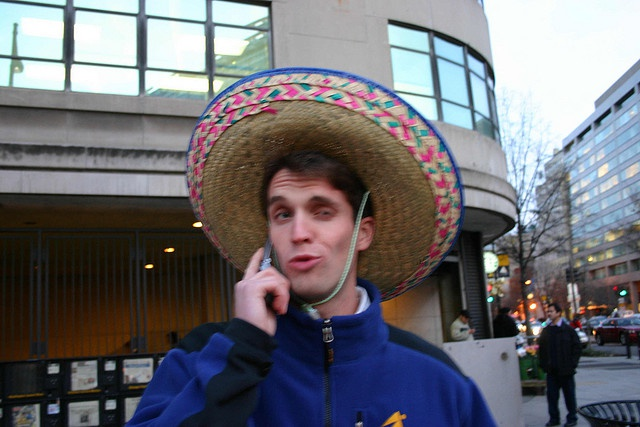Describe the objects in this image and their specific colors. I can see people in darkblue, navy, black, brown, and maroon tones, people in darkblue, black, and gray tones, car in darkblue, black, gray, and blue tones, people in darkblue, gray, black, and maroon tones, and people in darkblue, black, gray, and maroon tones in this image. 